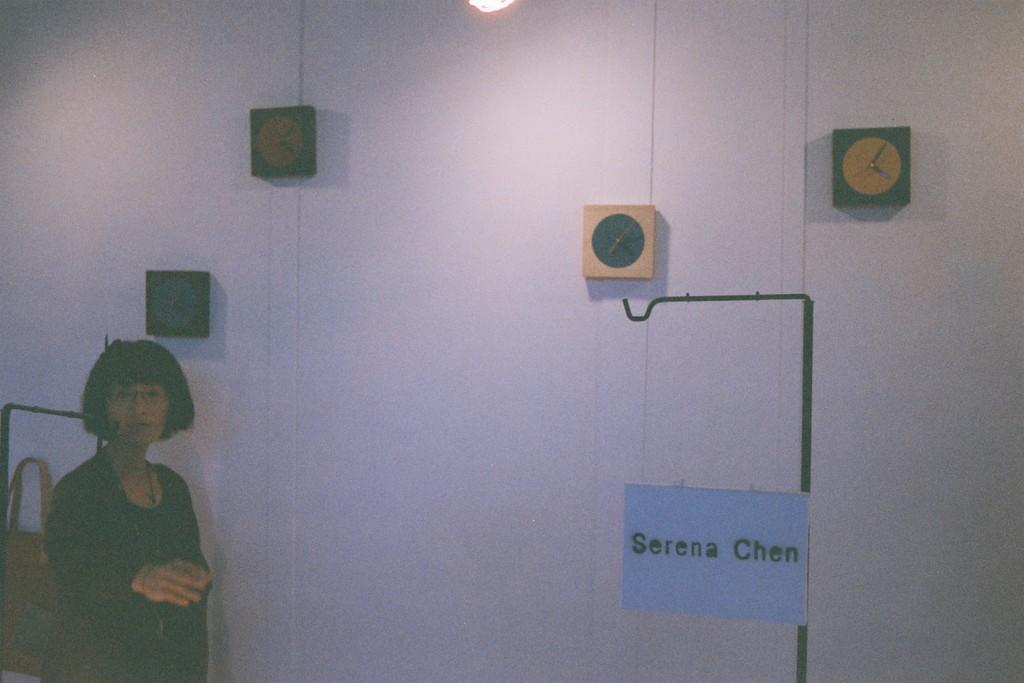Please provide a concise description of this image. In this picture, there is a woman at the bottom left. In the center, there is a wall with clocks and text. 